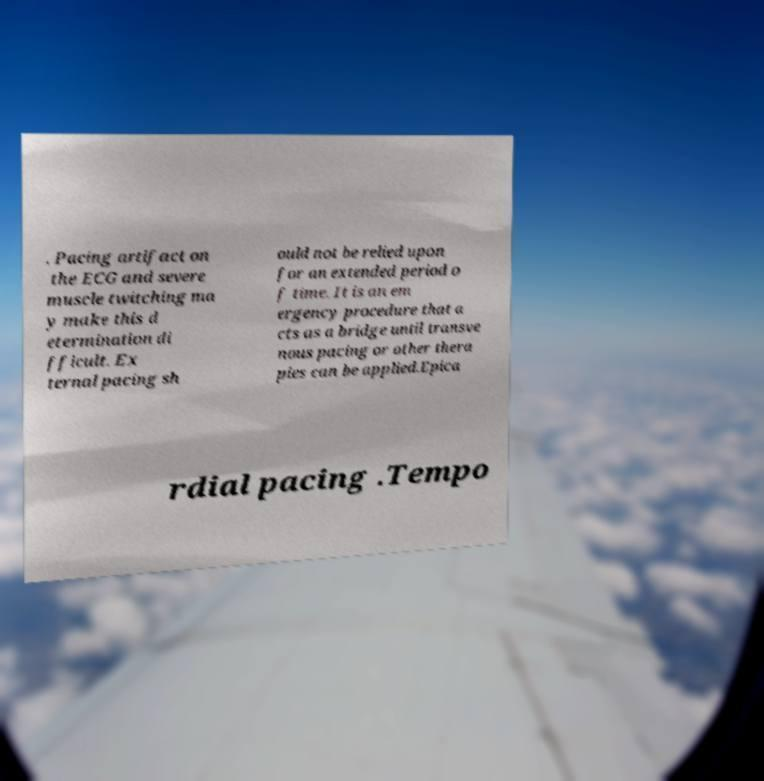Please read and relay the text visible in this image. What does it say? . Pacing artifact on the ECG and severe muscle twitching ma y make this d etermination di fficult. Ex ternal pacing sh ould not be relied upon for an extended period o f time. It is an em ergency procedure that a cts as a bridge until transve nous pacing or other thera pies can be applied.Epica rdial pacing .Tempo 